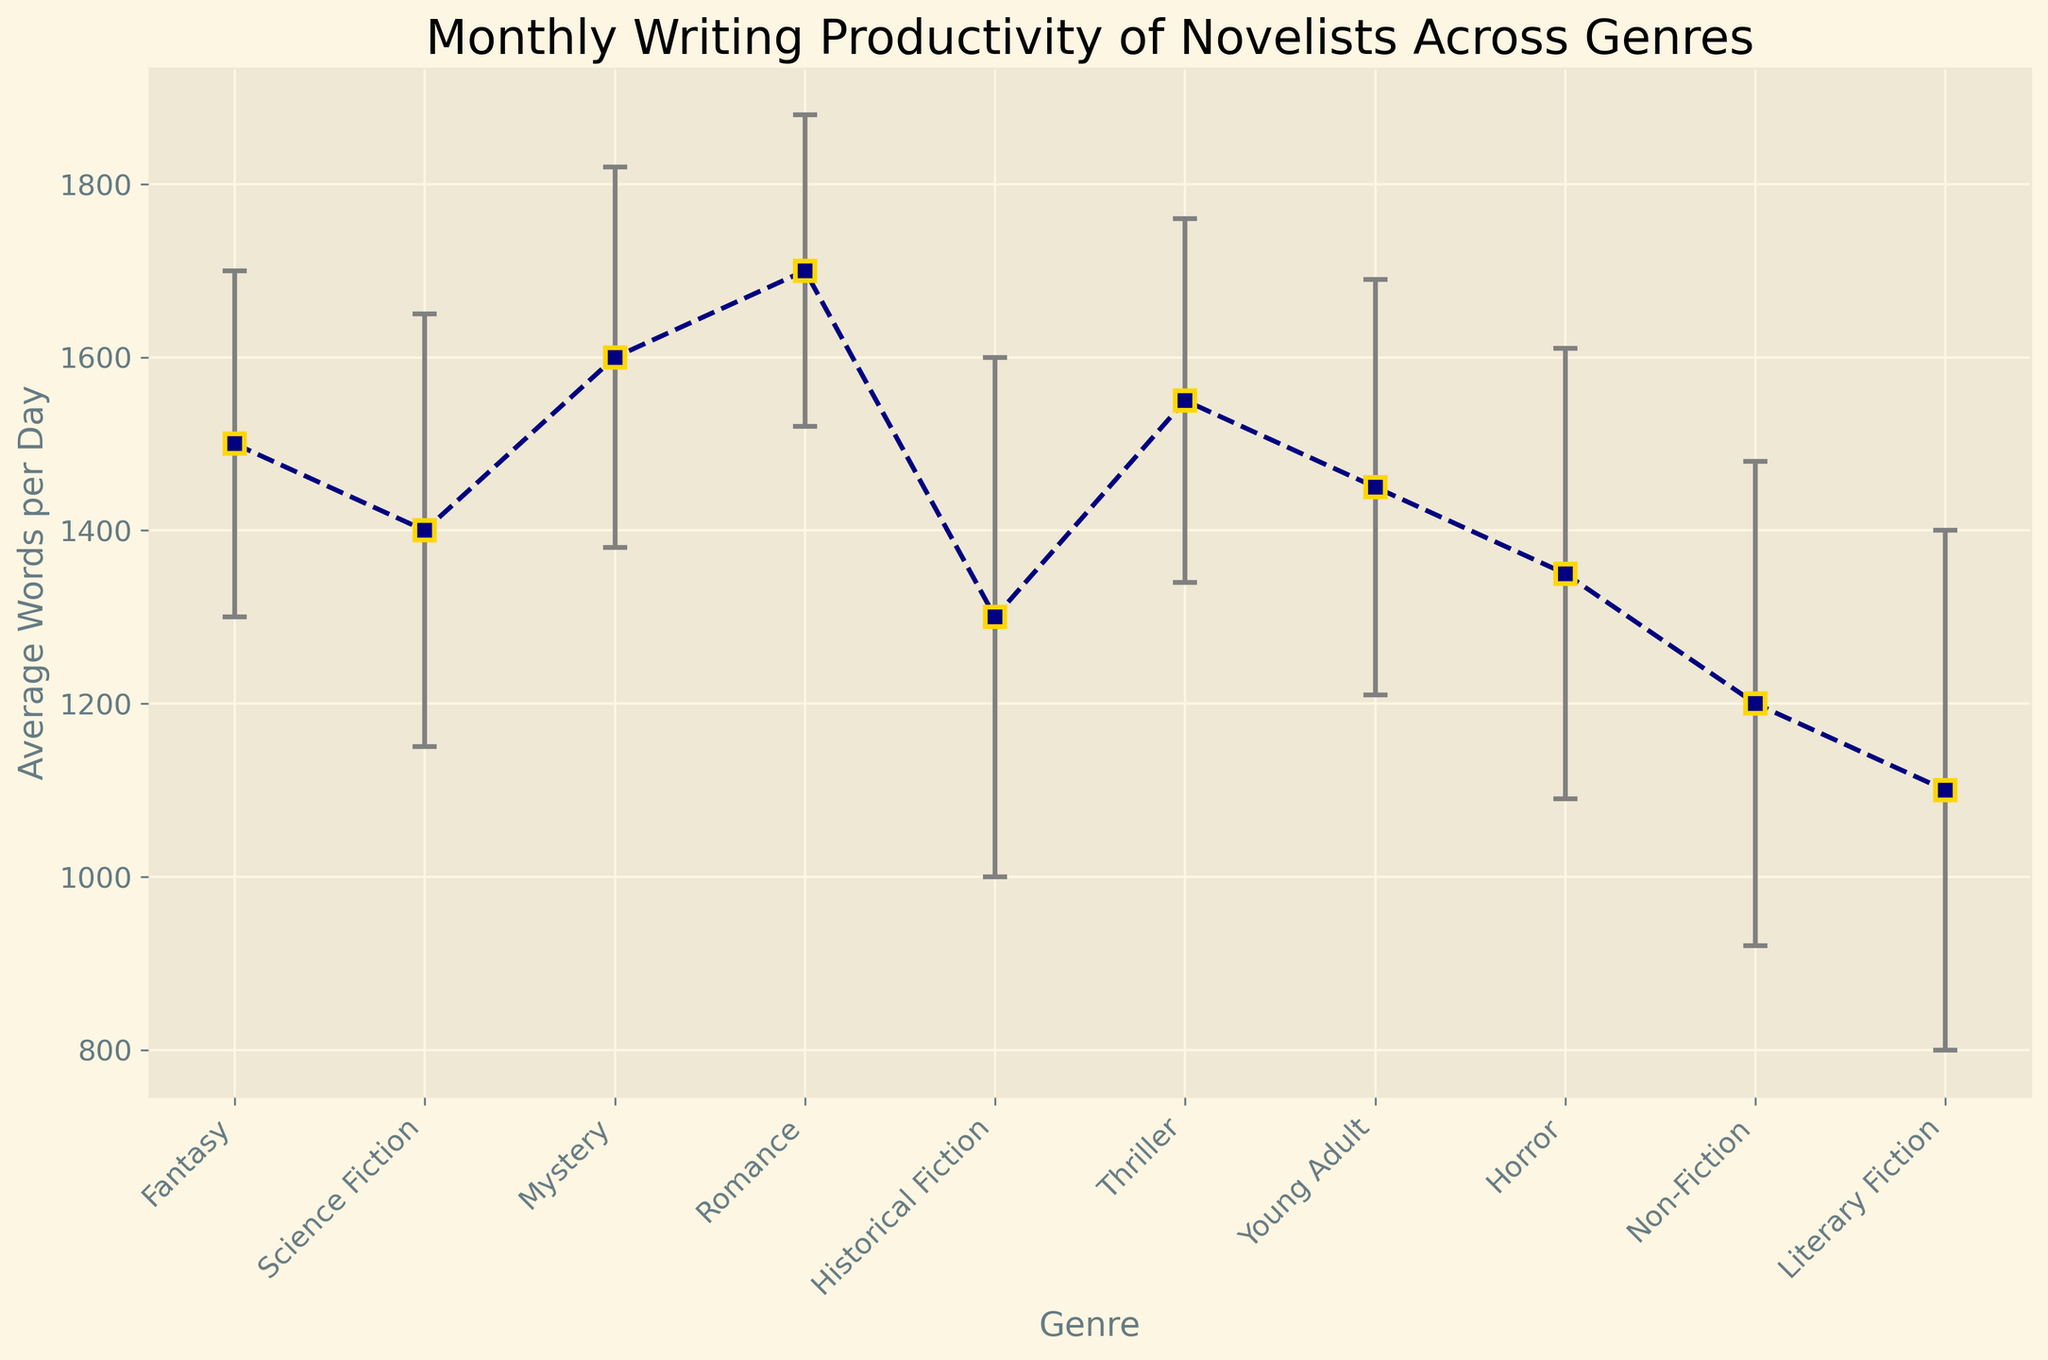What is the genre with the highest average words per day? The genre with the highest average words per day can be identified by looking for the tallest marker on the plot. Romance has the tallest marker.
Answer: Romance Which genre has the highest variability in writing productivity? The genre with the highest variability can be identified by the length of the error bars. Historical Fiction has the longest error bar.
Answer: Historical Fiction Which two genres have the closest average words per day? To find the two genres with the closest average words per day, we look for the markers that are at nearly the same height. Science Fiction and Young Adult are very close to each other.
Answer: Science Fiction and Young Adult What is the difference in average words per day between Mystery and Literary Fiction? Subtract the average words per day of Literary Fiction from that of Mystery. Mystery: 1600, Literary Fiction: 1100, so the difference is 1600 - 1100 = 500.
Answer: 500 Among the genres with the lowest productivity, which has a higher standard deviation, Non-Fiction or Literary Fiction? Compare the lengths of the error bars for Non-Fiction and Literary Fiction, which are the genres with low average words per day. Literary Fiction has a longer error bar indicating a higher standard deviation.
Answer: Literary Fiction What is the average of the average words per day for Fantasy, Science Fiction, and Historical Fiction? Add the average words per day for Fantasy, Science Fiction, and Historical Fiction, then divide by 3. (Fantasy: 1500, Science Fiction: 1400, Historical Fiction: 1300). (1500 + 1400 + 1300) / 3 = 4200 / 3 = 1400.
Answer: 1400 Which genre has a higher writing productivity, Thriller or Horror? Compare the average words per day markers for Thriller and Horror. Thriller has an average of 1550 while Horror has an average of 1350.
Answer: Thriller How many genres have an average words per day that falls between 1300 and 1600? Count the number of markers with average words between 1300 and 1600. Fantasy, Science Fiction, Mystery, Historical Fiction, Thriller, Young Adult, and Horror fit this criteria, so there are seven.
Answer: 7 Which genre has the smallest standard deviation? Identify the shortest error bar on the plot. Romance has the shortest error bar, indicating the smallest standard deviation.
Answer: Romance 